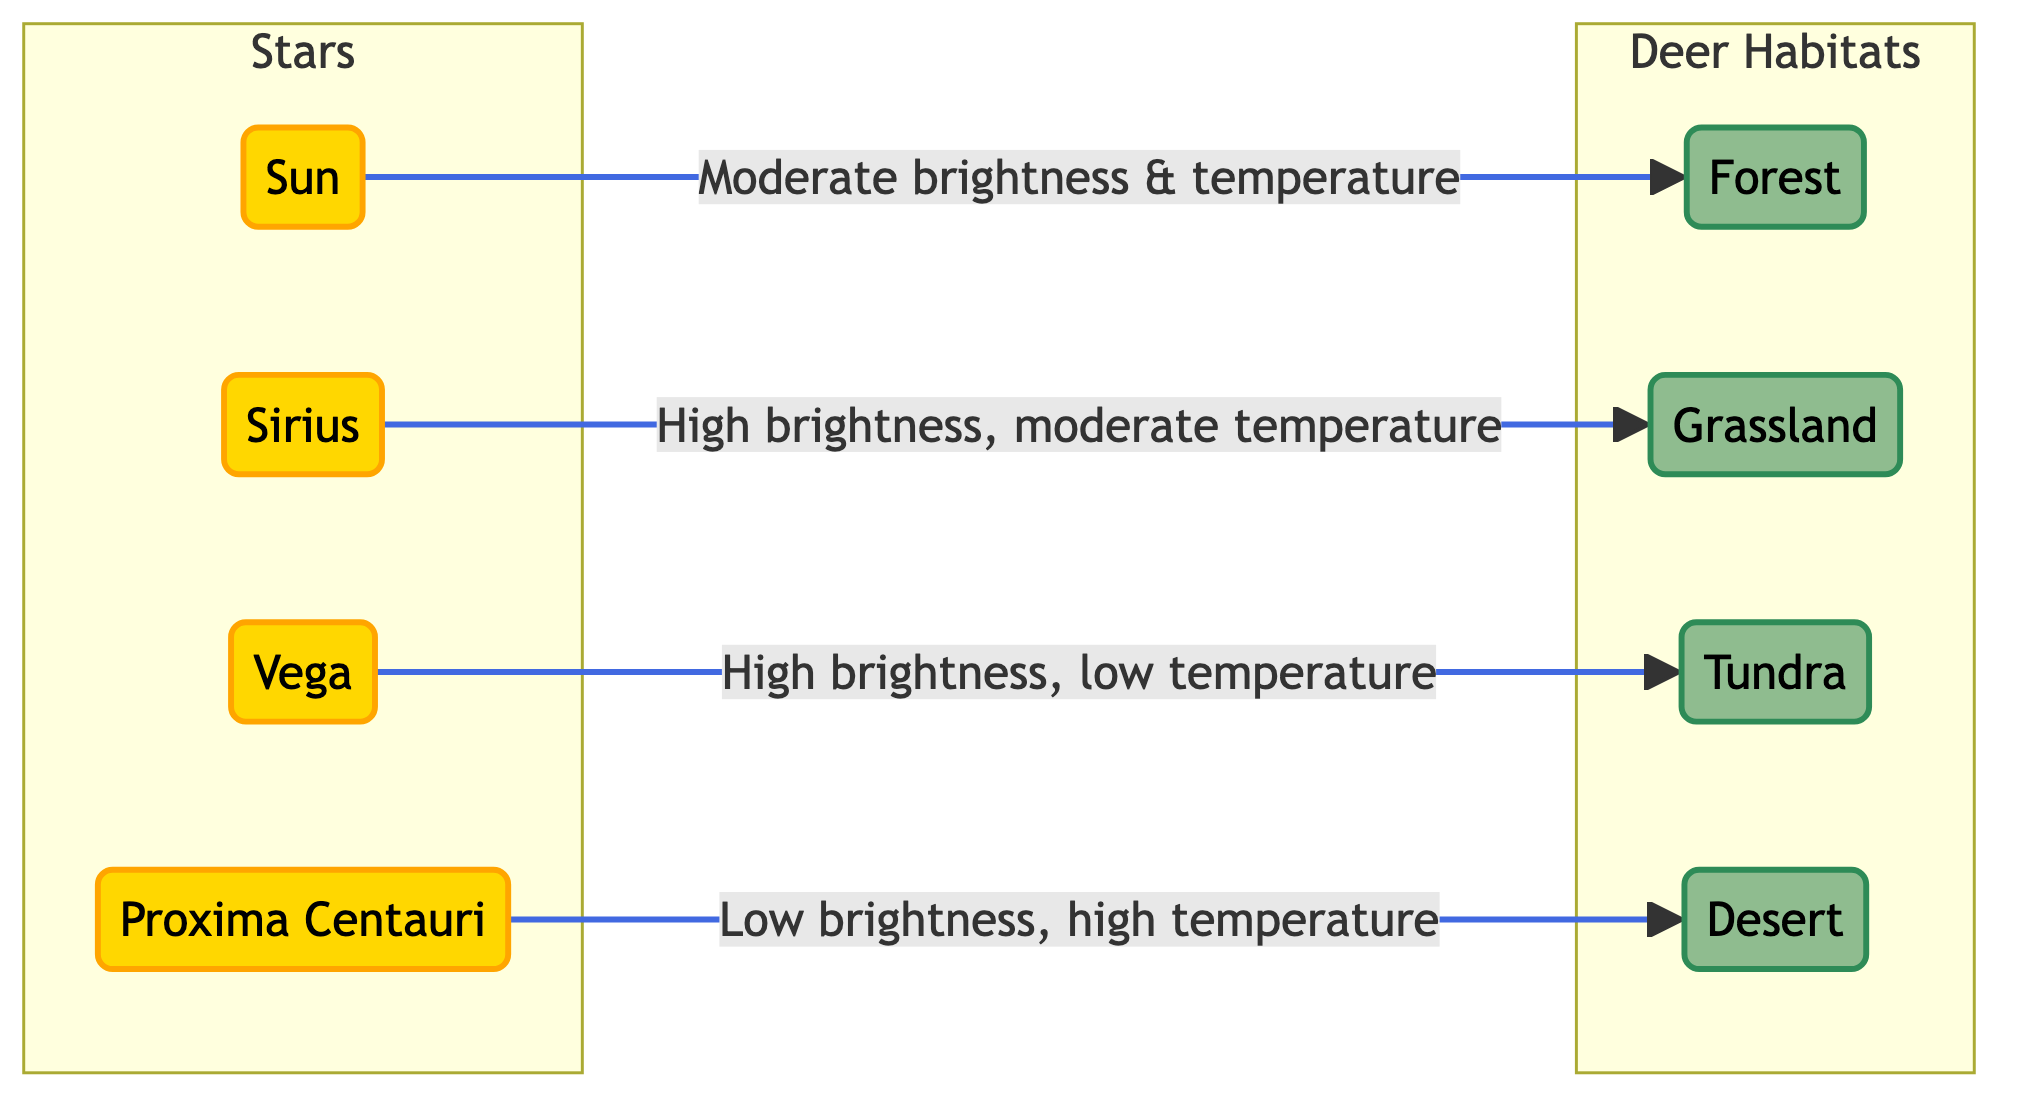What is the highest brightness star in the diagram? The diagram shows four stars, with Sirius and Vega both being classified as high brightness. However, the highest brightness star indicated is Sirius, as it is labeled as "High brightness, moderate temperature" which implies it stands out among the other stars.
Answer: Sirius Which star corresponds to the forest habitat? The diagram shows an arrow from the Sun to the Forest habitat, indicating a direct connection between them. This means the Sun is the star that corresponds to the forest habitat.
Answer: Sun How many deer habitats are represented in the diagram? The diagram includes four distinct habitats: Forest, Grassland, Tundra, and Desert. By counting these written habitats, we determine there are a total of four.
Answer: 4 What is the brightness level of Proxima Centauri? The diagram states that Proxima Centauri has a "Low brightness, high temperature" as its characteristics. Therefore, the brightness level of Proxima Centauri is categorized as low.
Answer: Low Which habitat is linked to the high brightness, low temperature star? The diagram indicates that Vega is the star that has "High brightness, low temperature" characteristics. The arrow connects Vega to the Tundra habitat, meaning Tundra is linked to this star.
Answer: Tundra What type of relationship exists between Sirius and the Grassland habitat? In the diagram, the relationship from Sirius to the Grassland habitat is expressed as an arrow, which signifies that there is a linkage indicating the characteristics of Sirius as a star correspond to conditions in the Grassland habitat.
Answer: High brightness, moderate temperature What is the temperature classification for the habitat associated with the Sun? The diagram places an arrow from the Sun to the Forest habitat describing "Moderate brightness & temperature" which informs us about the temperature classification relevant to this habitat linked to the Sun.
Answer: Moderate temperature How many edges connect stars to habitats in the diagram? The diagram showcases four direct connections (edges) between stars and habitats, one for each star linking them with a specific habitat. Counting these connections gives us a total of four edges.
Answer: 4 What is the environment type linked with the star that has low brightness? Proxima Centauri is explicitly noted to have "Low brightness," and the diagram connects it to the Desert habitat with an arrow, indicating this direct link to the environmental type.
Answer: Desert 